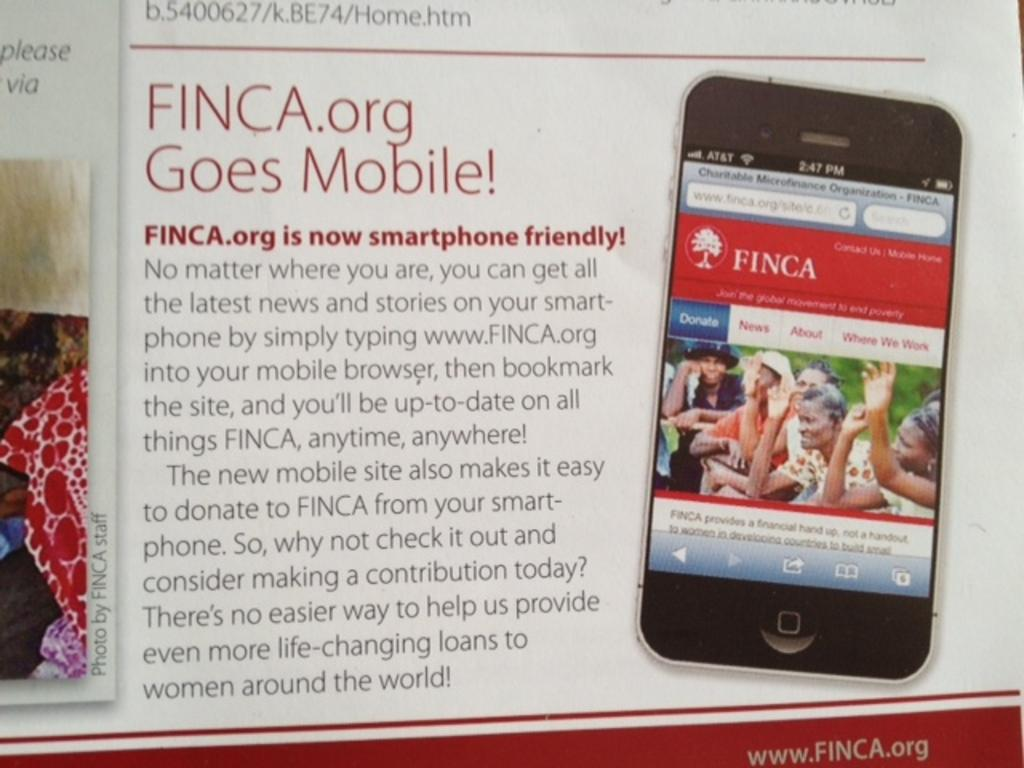<image>
Describe the image concisely. a page that says 'finca.org goes mobile!' on it 